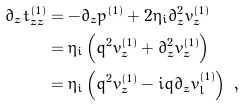<formula> <loc_0><loc_0><loc_500><loc_500>\partial _ { z } t ^ { ( 1 ) } _ { z z } & = - \partial _ { z } p ^ { ( 1 ) } + 2 \eta _ { i } \partial _ { z } ^ { 2 } v ^ { ( 1 ) } _ { z } \\ & = \eta _ { i } \left ( q ^ { 2 } v ^ { ( 1 ) } _ { z } + \partial _ { z } ^ { 2 } v ^ { ( 1 ) } _ { z } \right ) \\ & = \eta _ { i } \left ( q ^ { 2 } v ^ { ( 1 ) } _ { z } - i q \partial _ { z } v ^ { ( 1 ) } _ { l } \right ) \ ,</formula> 